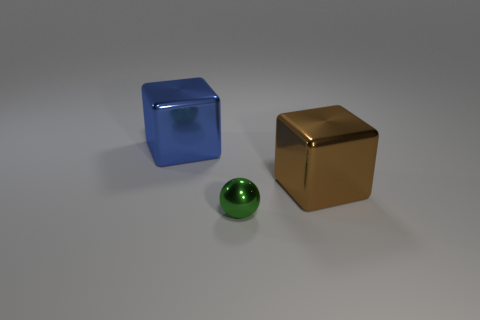Add 2 small red rubber things. How many objects exist? 5 Subtract all spheres. How many objects are left? 2 Add 1 green shiny balls. How many green shiny balls are left? 2 Add 2 yellow matte cylinders. How many yellow matte cylinders exist? 2 Subtract 1 green spheres. How many objects are left? 2 Subtract all purple matte things. Subtract all brown blocks. How many objects are left? 2 